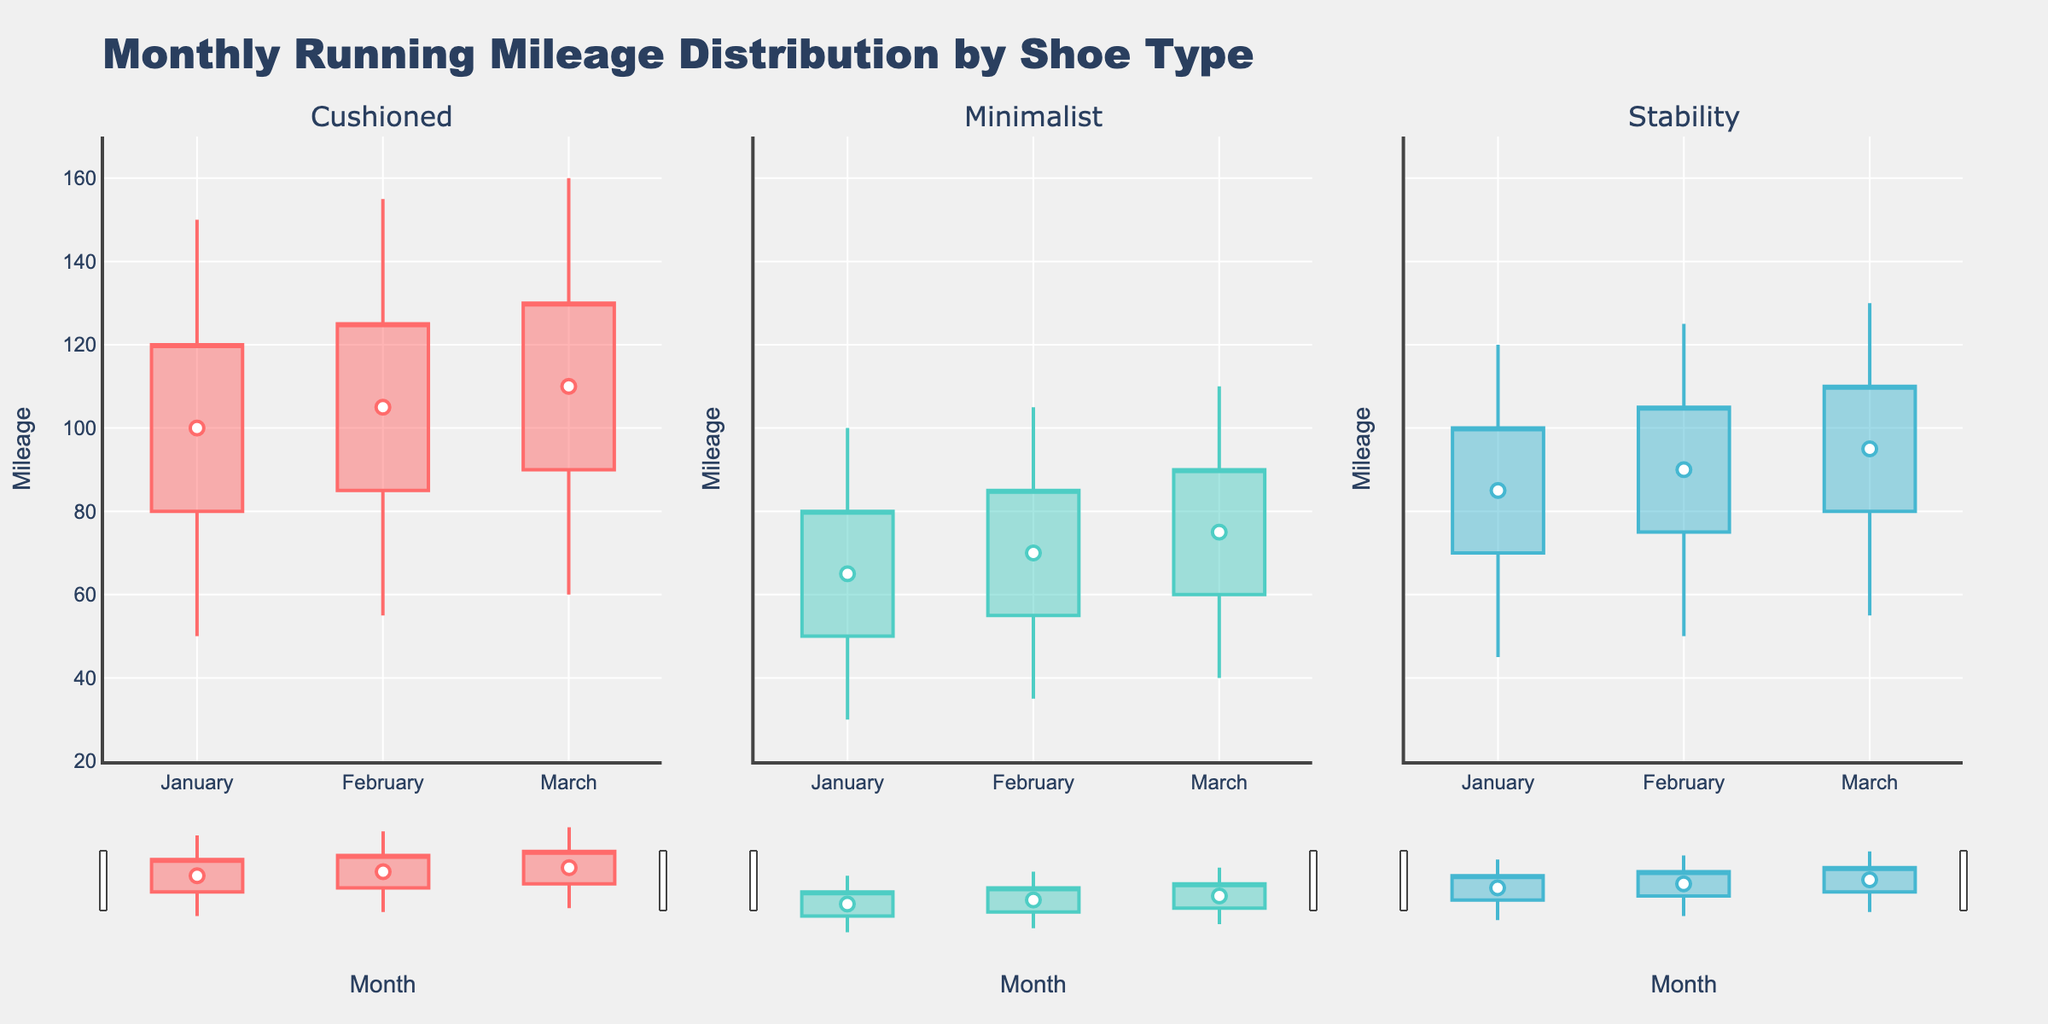What's the title of the figure? The title of the figure is located at the top and summarizes the content.
Answer: Monthly Running Mileage Distribution by Shoe Type What's the range of the y-axis? The y-axis range can be seen on the left side of the figure, from the bottom to the top.
Answer: 20 to 170 Which month and shoe type combination has the highest mileage? Look at the topmost point of the candlesticks across all months and shoe types.
Answer: Cushioned in March What's the median mileage for minimalist shoes in February? The median mileage is indicated by a white marker within the candlesticks representing the second quartile (Q2).
Answer: 70 Compare the interquartile range (IQR) for cushioned shoes in January and March. Which month has a larger IQR? IQR is calculated by subtracting Q1 from Q3. For January, it is 120 - 80. For March, it is 130 - 90.
Answer: March Which shoe type has the lowest mileage recorded, and in which month? Look at the bottommost points of the candlesticks across all months and shoe types.
Answer: Minimalist in January What is the difference between the highest and lowest mileage for stability shoes in February? The difference is calculated by subtracting the lowest mileage from the highest mileage for that month and shoe type. For February, it is 125 - 50.
Answer: 75 Which shoe type shows the least variability in mileage in January? Variability can be assessed by looking at the height of the candlestick bars and the distance between the lowest and highest points.
Answer: Minimalist Across all three shoe types, which month shows the most consistent median mileage? Check the scatter plots representing median mileage and compare the consistency across the months.
Answer: March What's the difference in median mileage between cushioned and minimalist shoes in January? The difference is obtained by subtracting the median mileage of minimalist from that of cushioned. In January, it is 100 - 65.
Answer: 35 